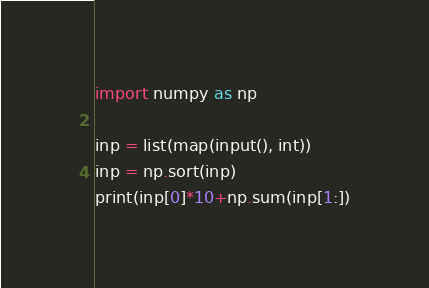<code> <loc_0><loc_0><loc_500><loc_500><_Python_>import numpy as np

inp = list(map(input(), int))
inp = np.sort(inp)
print(inp[0]*10+np.sum(inp[1:])</code> 